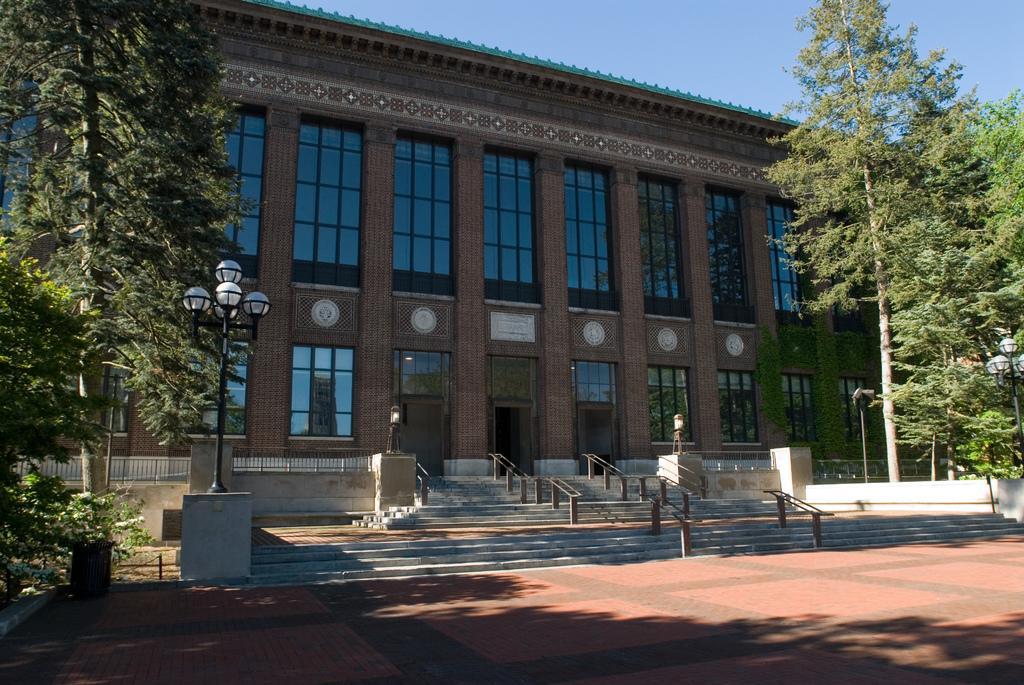Describe this image in one or two sentences. In this image there is a building in the center, on the left side of the building in the front there is a tree and there is a pole. On the right side in the front of the building there are trees. In front of the building in the center there are stairs. 